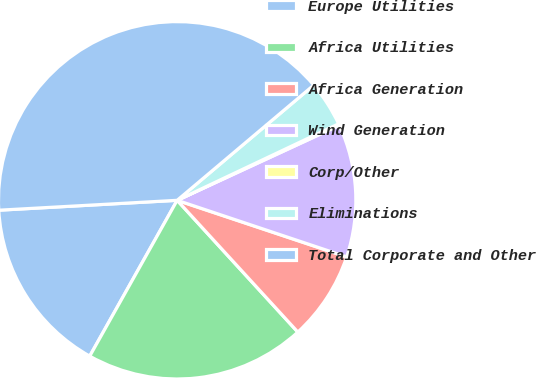Convert chart to OTSL. <chart><loc_0><loc_0><loc_500><loc_500><pie_chart><fcel>Europe Utilities<fcel>Africa Utilities<fcel>Africa Generation<fcel>Wind Generation<fcel>Corp/Other<fcel>Eliminations<fcel>Total Corporate and Other<nl><fcel>15.98%<fcel>19.94%<fcel>8.07%<fcel>12.02%<fcel>0.15%<fcel>4.11%<fcel>39.73%<nl></chart> 